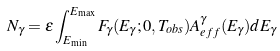<formula> <loc_0><loc_0><loc_500><loc_500>N _ { \gamma } = \epsilon \int ^ { E _ { \max } } _ { E _ { \min } } F _ { \gamma } ( E _ { \gamma } ; 0 , T _ { o b s } ) A ^ { \gamma } _ { e f f } ( E _ { \gamma } ) d E _ { \gamma }</formula> 